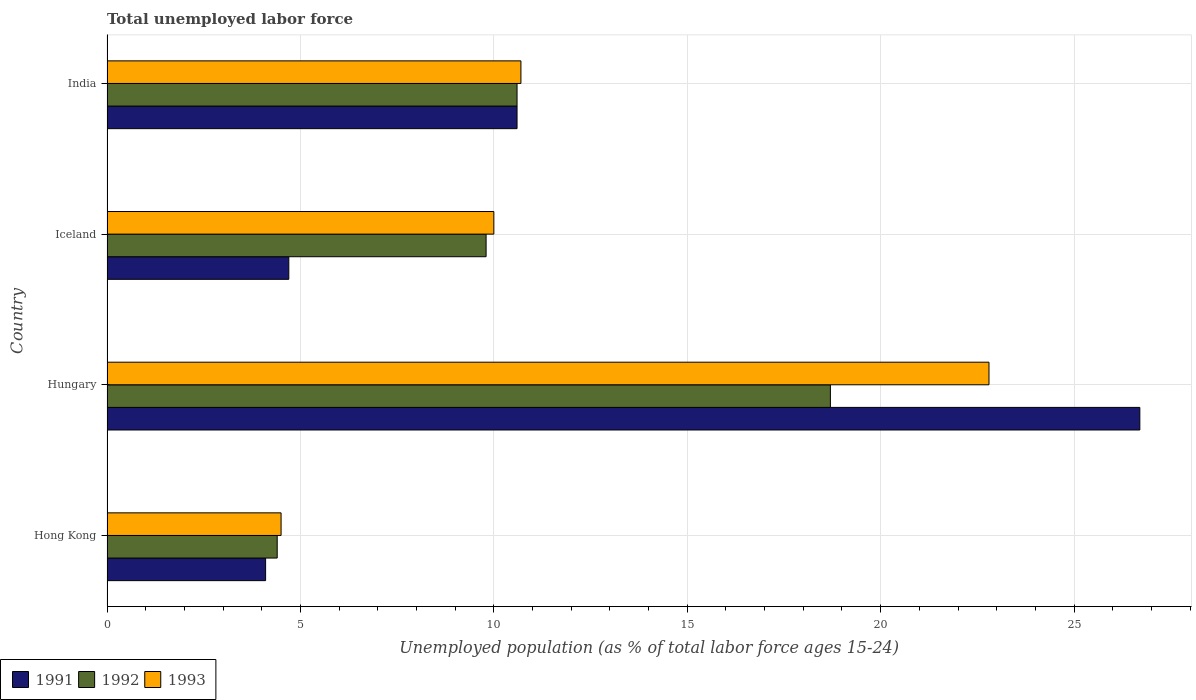How many different coloured bars are there?
Offer a terse response. 3. How many bars are there on the 1st tick from the top?
Provide a succinct answer. 3. What is the label of the 3rd group of bars from the top?
Your answer should be very brief. Hungary. In how many cases, is the number of bars for a given country not equal to the number of legend labels?
Provide a short and direct response. 0. What is the percentage of unemployed population in in 1993 in Hong Kong?
Provide a succinct answer. 4.5. Across all countries, what is the maximum percentage of unemployed population in in 1991?
Offer a very short reply. 26.7. Across all countries, what is the minimum percentage of unemployed population in in 1992?
Give a very brief answer. 4.4. In which country was the percentage of unemployed population in in 1991 maximum?
Offer a very short reply. Hungary. In which country was the percentage of unemployed population in in 1991 minimum?
Your answer should be compact. Hong Kong. What is the total percentage of unemployed population in in 1992 in the graph?
Your response must be concise. 43.5. What is the difference between the percentage of unemployed population in in 1993 in Iceland and that in India?
Make the answer very short. -0.7. What is the difference between the percentage of unemployed population in in 1992 in Iceland and the percentage of unemployed population in in 1993 in Hungary?
Offer a terse response. -13. What is the average percentage of unemployed population in in 1992 per country?
Keep it short and to the point. 10.88. What is the difference between the percentage of unemployed population in in 1992 and percentage of unemployed population in in 1993 in Hungary?
Your answer should be very brief. -4.1. In how many countries, is the percentage of unemployed population in in 1991 greater than 27 %?
Your answer should be compact. 0. What is the ratio of the percentage of unemployed population in in 1991 in Hungary to that in India?
Your answer should be compact. 2.52. What is the difference between the highest and the second highest percentage of unemployed population in in 1991?
Give a very brief answer. 16.1. What is the difference between the highest and the lowest percentage of unemployed population in in 1992?
Provide a succinct answer. 14.3. Is the sum of the percentage of unemployed population in in 1993 in Hong Kong and India greater than the maximum percentage of unemployed population in in 1991 across all countries?
Provide a short and direct response. No. How many bars are there?
Your answer should be very brief. 12. Are all the bars in the graph horizontal?
Your answer should be compact. Yes. How many countries are there in the graph?
Provide a succinct answer. 4. What is the difference between two consecutive major ticks on the X-axis?
Give a very brief answer. 5. Does the graph contain any zero values?
Offer a very short reply. No. Where does the legend appear in the graph?
Your answer should be compact. Bottom left. What is the title of the graph?
Make the answer very short. Total unemployed labor force. What is the label or title of the X-axis?
Your response must be concise. Unemployed population (as % of total labor force ages 15-24). What is the Unemployed population (as % of total labor force ages 15-24) of 1991 in Hong Kong?
Offer a very short reply. 4.1. What is the Unemployed population (as % of total labor force ages 15-24) in 1992 in Hong Kong?
Offer a very short reply. 4.4. What is the Unemployed population (as % of total labor force ages 15-24) of 1991 in Hungary?
Keep it short and to the point. 26.7. What is the Unemployed population (as % of total labor force ages 15-24) of 1992 in Hungary?
Offer a terse response. 18.7. What is the Unemployed population (as % of total labor force ages 15-24) in 1993 in Hungary?
Keep it short and to the point. 22.8. What is the Unemployed population (as % of total labor force ages 15-24) of 1991 in Iceland?
Give a very brief answer. 4.7. What is the Unemployed population (as % of total labor force ages 15-24) in 1992 in Iceland?
Make the answer very short. 9.8. What is the Unemployed population (as % of total labor force ages 15-24) in 1991 in India?
Your response must be concise. 10.6. What is the Unemployed population (as % of total labor force ages 15-24) of 1992 in India?
Make the answer very short. 10.6. What is the Unemployed population (as % of total labor force ages 15-24) of 1993 in India?
Provide a short and direct response. 10.7. Across all countries, what is the maximum Unemployed population (as % of total labor force ages 15-24) of 1991?
Provide a succinct answer. 26.7. Across all countries, what is the maximum Unemployed population (as % of total labor force ages 15-24) of 1992?
Your answer should be very brief. 18.7. Across all countries, what is the maximum Unemployed population (as % of total labor force ages 15-24) of 1993?
Offer a terse response. 22.8. Across all countries, what is the minimum Unemployed population (as % of total labor force ages 15-24) of 1991?
Give a very brief answer. 4.1. Across all countries, what is the minimum Unemployed population (as % of total labor force ages 15-24) of 1992?
Give a very brief answer. 4.4. Across all countries, what is the minimum Unemployed population (as % of total labor force ages 15-24) of 1993?
Provide a succinct answer. 4.5. What is the total Unemployed population (as % of total labor force ages 15-24) in 1991 in the graph?
Your response must be concise. 46.1. What is the total Unemployed population (as % of total labor force ages 15-24) of 1992 in the graph?
Offer a very short reply. 43.5. What is the total Unemployed population (as % of total labor force ages 15-24) in 1993 in the graph?
Provide a succinct answer. 48. What is the difference between the Unemployed population (as % of total labor force ages 15-24) of 1991 in Hong Kong and that in Hungary?
Your answer should be very brief. -22.6. What is the difference between the Unemployed population (as % of total labor force ages 15-24) in 1992 in Hong Kong and that in Hungary?
Ensure brevity in your answer.  -14.3. What is the difference between the Unemployed population (as % of total labor force ages 15-24) in 1993 in Hong Kong and that in Hungary?
Provide a succinct answer. -18.3. What is the difference between the Unemployed population (as % of total labor force ages 15-24) in 1993 in Hong Kong and that in India?
Ensure brevity in your answer.  -6.2. What is the difference between the Unemployed population (as % of total labor force ages 15-24) of 1991 in Hungary and that in Iceland?
Keep it short and to the point. 22. What is the difference between the Unemployed population (as % of total labor force ages 15-24) of 1992 in Hungary and that in Iceland?
Your response must be concise. 8.9. What is the difference between the Unemployed population (as % of total labor force ages 15-24) in 1991 in Hungary and that in India?
Your answer should be very brief. 16.1. What is the difference between the Unemployed population (as % of total labor force ages 15-24) in 1992 in Hungary and that in India?
Provide a short and direct response. 8.1. What is the difference between the Unemployed population (as % of total labor force ages 15-24) in 1993 in Hungary and that in India?
Provide a succinct answer. 12.1. What is the difference between the Unemployed population (as % of total labor force ages 15-24) in 1992 in Iceland and that in India?
Provide a succinct answer. -0.8. What is the difference between the Unemployed population (as % of total labor force ages 15-24) of 1993 in Iceland and that in India?
Give a very brief answer. -0.7. What is the difference between the Unemployed population (as % of total labor force ages 15-24) of 1991 in Hong Kong and the Unemployed population (as % of total labor force ages 15-24) of 1992 in Hungary?
Provide a succinct answer. -14.6. What is the difference between the Unemployed population (as % of total labor force ages 15-24) in 1991 in Hong Kong and the Unemployed population (as % of total labor force ages 15-24) in 1993 in Hungary?
Your response must be concise. -18.7. What is the difference between the Unemployed population (as % of total labor force ages 15-24) of 1992 in Hong Kong and the Unemployed population (as % of total labor force ages 15-24) of 1993 in Hungary?
Provide a succinct answer. -18.4. What is the difference between the Unemployed population (as % of total labor force ages 15-24) in 1992 in Hong Kong and the Unemployed population (as % of total labor force ages 15-24) in 1993 in Iceland?
Give a very brief answer. -5.6. What is the difference between the Unemployed population (as % of total labor force ages 15-24) in 1991 in Hungary and the Unemployed population (as % of total labor force ages 15-24) in 1992 in Iceland?
Your answer should be compact. 16.9. What is the difference between the Unemployed population (as % of total labor force ages 15-24) in 1991 in Hungary and the Unemployed population (as % of total labor force ages 15-24) in 1993 in Iceland?
Offer a terse response. 16.7. What is the difference between the Unemployed population (as % of total labor force ages 15-24) of 1992 in Hungary and the Unemployed population (as % of total labor force ages 15-24) of 1993 in Iceland?
Give a very brief answer. 8.7. What is the difference between the Unemployed population (as % of total labor force ages 15-24) of 1992 in Hungary and the Unemployed population (as % of total labor force ages 15-24) of 1993 in India?
Offer a terse response. 8. What is the average Unemployed population (as % of total labor force ages 15-24) in 1991 per country?
Ensure brevity in your answer.  11.53. What is the average Unemployed population (as % of total labor force ages 15-24) of 1992 per country?
Provide a short and direct response. 10.88. What is the difference between the Unemployed population (as % of total labor force ages 15-24) in 1991 and Unemployed population (as % of total labor force ages 15-24) in 1992 in Hungary?
Your answer should be very brief. 8. What is the difference between the Unemployed population (as % of total labor force ages 15-24) of 1992 and Unemployed population (as % of total labor force ages 15-24) of 1993 in Hungary?
Ensure brevity in your answer.  -4.1. What is the difference between the Unemployed population (as % of total labor force ages 15-24) in 1991 and Unemployed population (as % of total labor force ages 15-24) in 1993 in Iceland?
Your answer should be very brief. -5.3. What is the difference between the Unemployed population (as % of total labor force ages 15-24) in 1992 and Unemployed population (as % of total labor force ages 15-24) in 1993 in Iceland?
Your answer should be compact. -0.2. What is the difference between the Unemployed population (as % of total labor force ages 15-24) in 1992 and Unemployed population (as % of total labor force ages 15-24) in 1993 in India?
Your answer should be compact. -0.1. What is the ratio of the Unemployed population (as % of total labor force ages 15-24) of 1991 in Hong Kong to that in Hungary?
Your response must be concise. 0.15. What is the ratio of the Unemployed population (as % of total labor force ages 15-24) of 1992 in Hong Kong to that in Hungary?
Keep it short and to the point. 0.24. What is the ratio of the Unemployed population (as % of total labor force ages 15-24) of 1993 in Hong Kong to that in Hungary?
Offer a very short reply. 0.2. What is the ratio of the Unemployed population (as % of total labor force ages 15-24) in 1991 in Hong Kong to that in Iceland?
Your answer should be compact. 0.87. What is the ratio of the Unemployed population (as % of total labor force ages 15-24) of 1992 in Hong Kong to that in Iceland?
Make the answer very short. 0.45. What is the ratio of the Unemployed population (as % of total labor force ages 15-24) in 1993 in Hong Kong to that in Iceland?
Ensure brevity in your answer.  0.45. What is the ratio of the Unemployed population (as % of total labor force ages 15-24) in 1991 in Hong Kong to that in India?
Offer a very short reply. 0.39. What is the ratio of the Unemployed population (as % of total labor force ages 15-24) in 1992 in Hong Kong to that in India?
Give a very brief answer. 0.42. What is the ratio of the Unemployed population (as % of total labor force ages 15-24) of 1993 in Hong Kong to that in India?
Ensure brevity in your answer.  0.42. What is the ratio of the Unemployed population (as % of total labor force ages 15-24) of 1991 in Hungary to that in Iceland?
Ensure brevity in your answer.  5.68. What is the ratio of the Unemployed population (as % of total labor force ages 15-24) in 1992 in Hungary to that in Iceland?
Keep it short and to the point. 1.91. What is the ratio of the Unemployed population (as % of total labor force ages 15-24) in 1993 in Hungary to that in Iceland?
Your response must be concise. 2.28. What is the ratio of the Unemployed population (as % of total labor force ages 15-24) of 1991 in Hungary to that in India?
Ensure brevity in your answer.  2.52. What is the ratio of the Unemployed population (as % of total labor force ages 15-24) in 1992 in Hungary to that in India?
Your answer should be compact. 1.76. What is the ratio of the Unemployed population (as % of total labor force ages 15-24) of 1993 in Hungary to that in India?
Give a very brief answer. 2.13. What is the ratio of the Unemployed population (as % of total labor force ages 15-24) of 1991 in Iceland to that in India?
Provide a succinct answer. 0.44. What is the ratio of the Unemployed population (as % of total labor force ages 15-24) in 1992 in Iceland to that in India?
Your response must be concise. 0.92. What is the ratio of the Unemployed population (as % of total labor force ages 15-24) of 1993 in Iceland to that in India?
Provide a short and direct response. 0.93. What is the difference between the highest and the second highest Unemployed population (as % of total labor force ages 15-24) of 1991?
Give a very brief answer. 16.1. What is the difference between the highest and the second highest Unemployed population (as % of total labor force ages 15-24) of 1993?
Provide a short and direct response. 12.1. What is the difference between the highest and the lowest Unemployed population (as % of total labor force ages 15-24) of 1991?
Your answer should be compact. 22.6. What is the difference between the highest and the lowest Unemployed population (as % of total labor force ages 15-24) of 1993?
Your response must be concise. 18.3. 